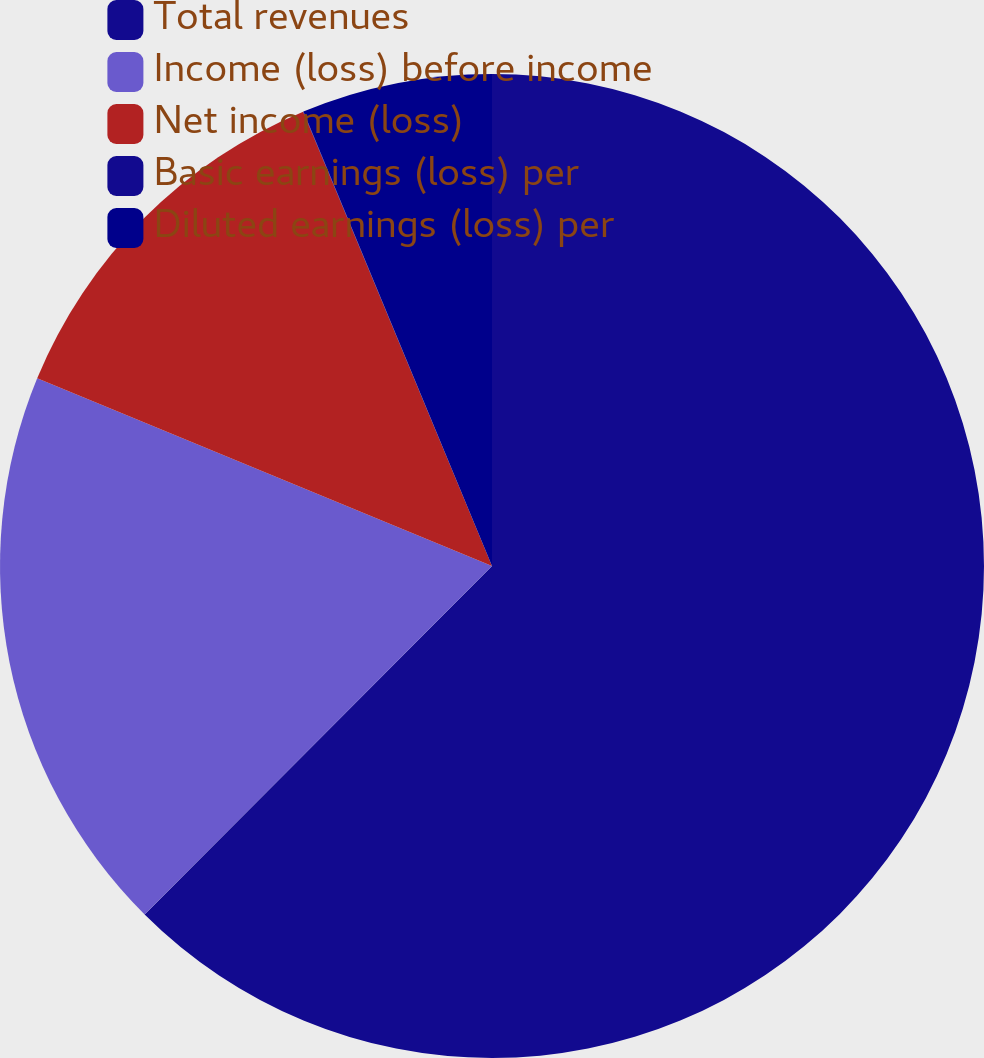Convert chart to OTSL. <chart><loc_0><loc_0><loc_500><loc_500><pie_chart><fcel>Total revenues<fcel>Income (loss) before income<fcel>Net income (loss)<fcel>Basic earnings (loss) per<fcel>Diluted earnings (loss) per<nl><fcel>62.47%<fcel>18.75%<fcel>12.5%<fcel>0.01%<fcel>6.26%<nl></chart> 